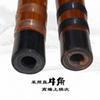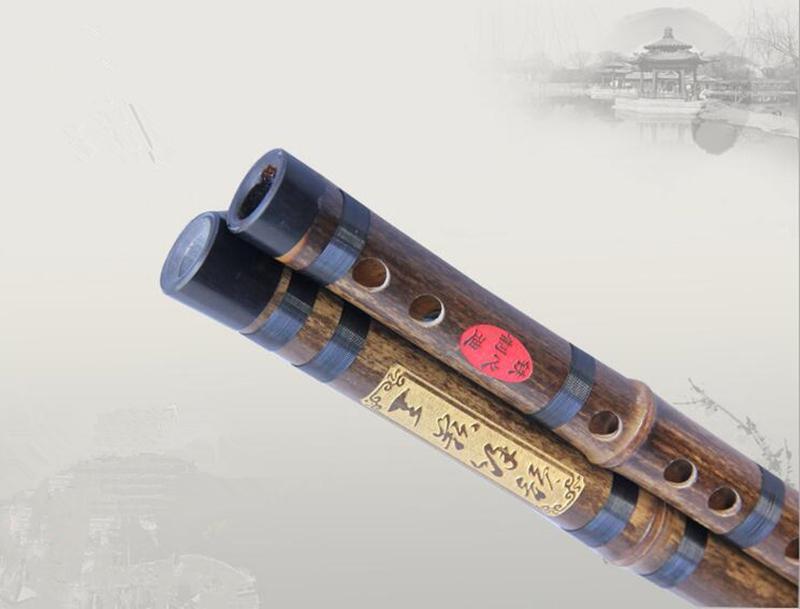The first image is the image on the left, the second image is the image on the right. Analyze the images presented: Is the assertion "There is a single flute in the left image." valid? Answer yes or no. No. The first image is the image on the left, the second image is the image on the right. Examine the images to the left and right. Is the description "One image contains a single flute, and the other image shows two silver metal ends that overlap." accurate? Answer yes or no. No. 